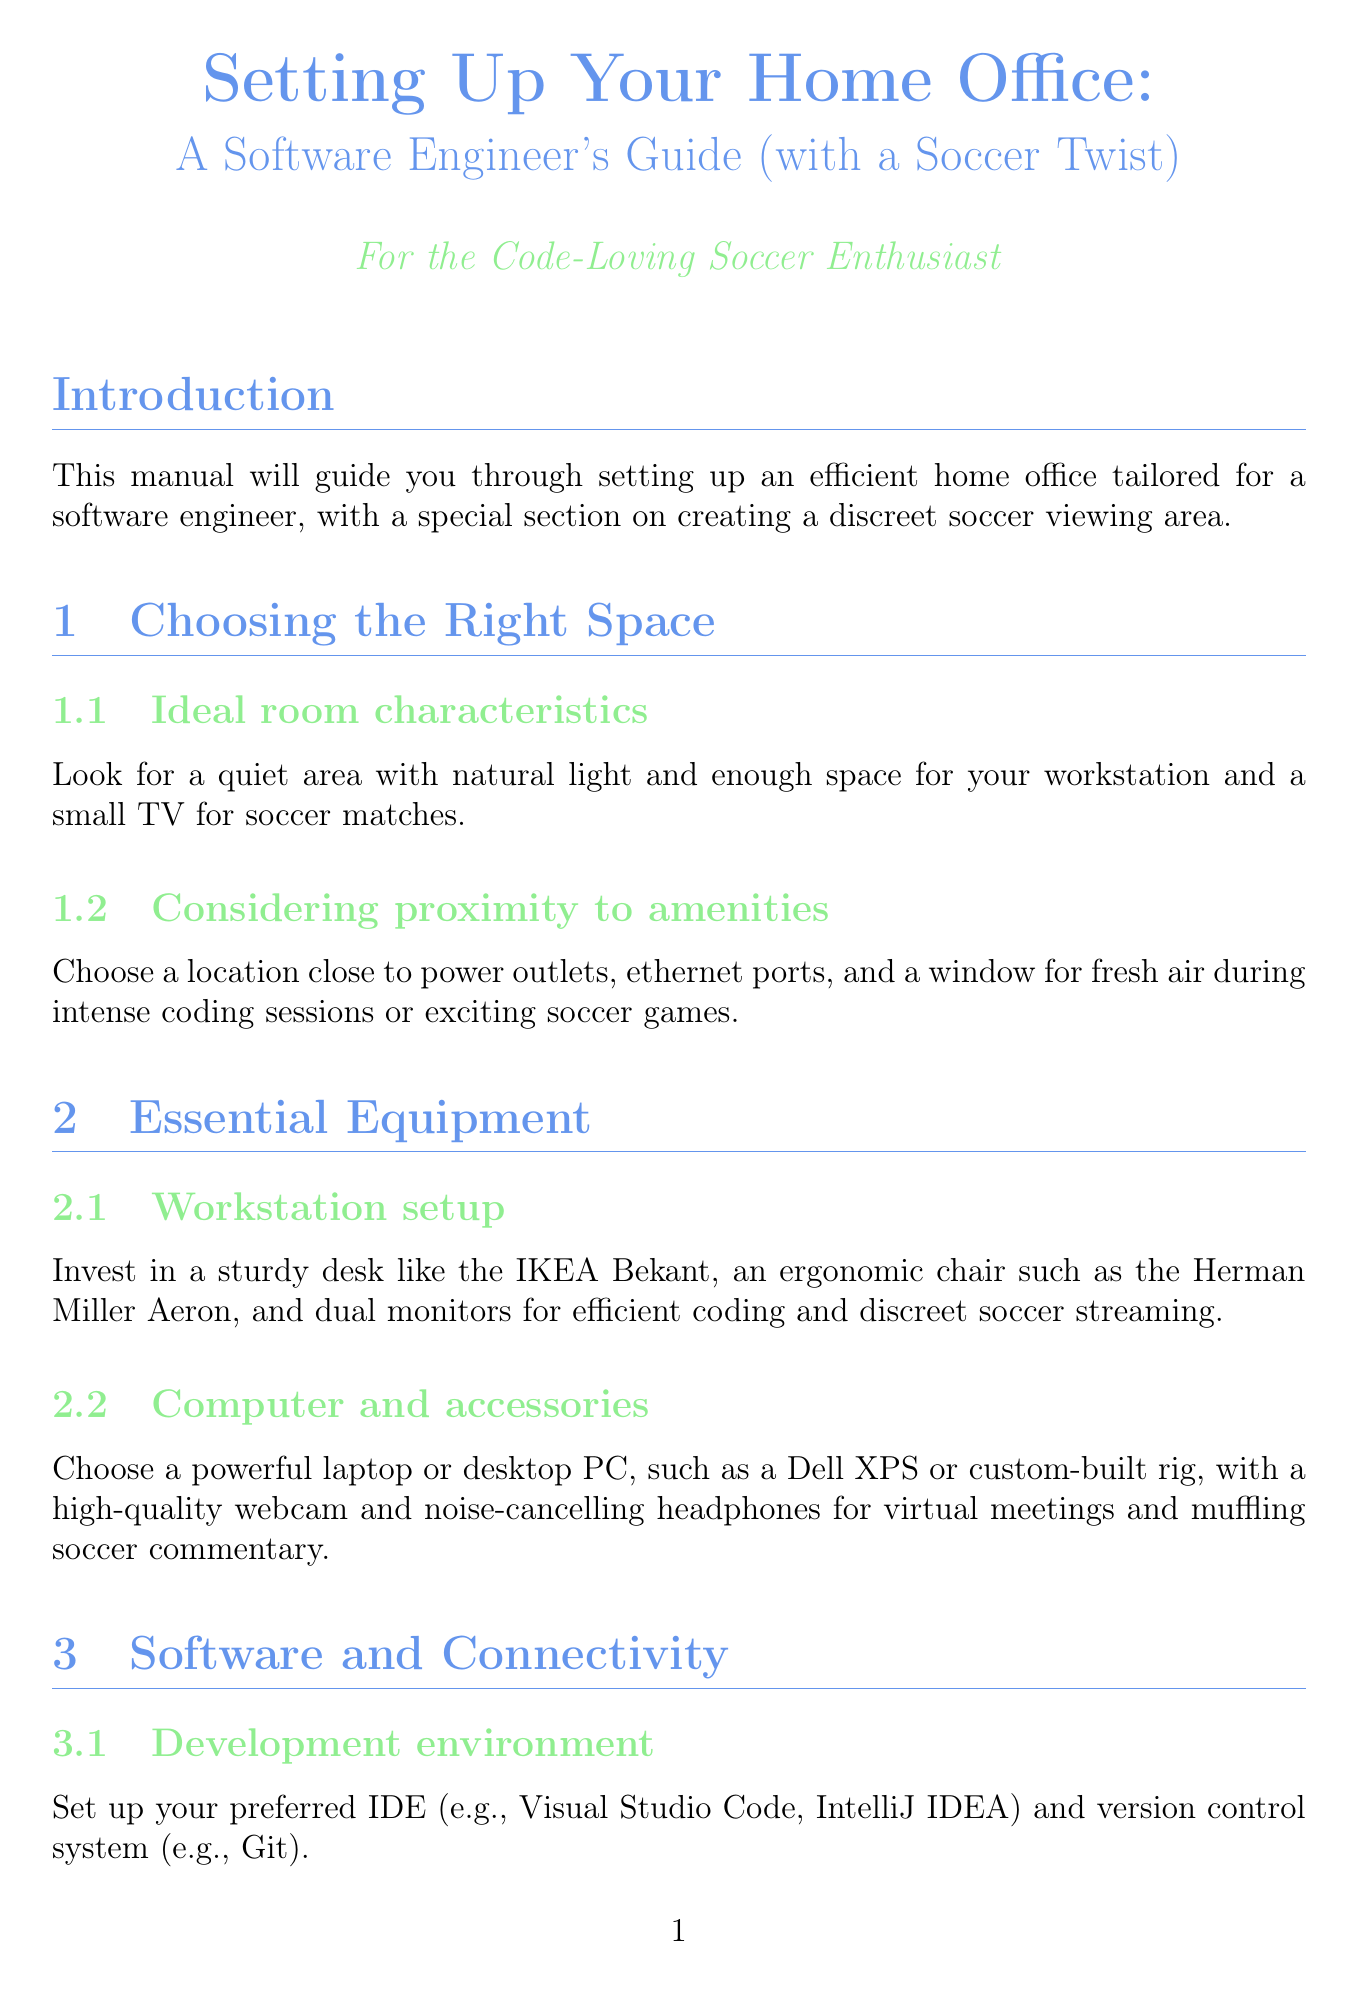What is the title of the manual? The title of the manual is clearly stated at the top section of the document.
Answer: Setting Up Your Home Office: A Software Engineer's Guide (with a Soccer Twist) What is the recommended ergonomic chair? The recommended ergonomic chair is mentioned under the Essential Equipment section.
Answer: Herman Miller Aeron What should you establish to maintain productivity? This information is provided in the Maintaining Work-Life Balance section.
Answer: Clear working hours What is a suggested streaming device for soccer matches? The manual specifies a couple of devices under the Creating a Discreet Soccer Viewing Area section.
Answer: Roku What should you use for cable management? The document suggests a method for keeping wires tidy in the Organizing Your Space section.
Answer: Cable ties How many monitors are recommended for efficient coding? This is specified in the Essential Equipment section as part of the workspace setup.
Answer: Dual monitors What should you consider when choosing your office space? This guidance is offered in the Choosing the Right Space section, mentioning key factors.
Answer: Quiet area What should you add for comfort in your workspace? The manual advises on enhancing the workspace environment in the Maintaining Work-Life Balance section.
Answer: Plants How can you quickly switch between work and soccer views? A method for making this switch is provided in the Creating a Discreet Soccer Viewing Area section.
Answer: Keyboard shortcuts 